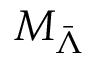Convert formula to latex. <formula><loc_0><loc_0><loc_500><loc_500>M _ { \bar { \Lambda } }</formula> 